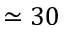Convert formula to latex. <formula><loc_0><loc_0><loc_500><loc_500>\simeq 3 0</formula> 